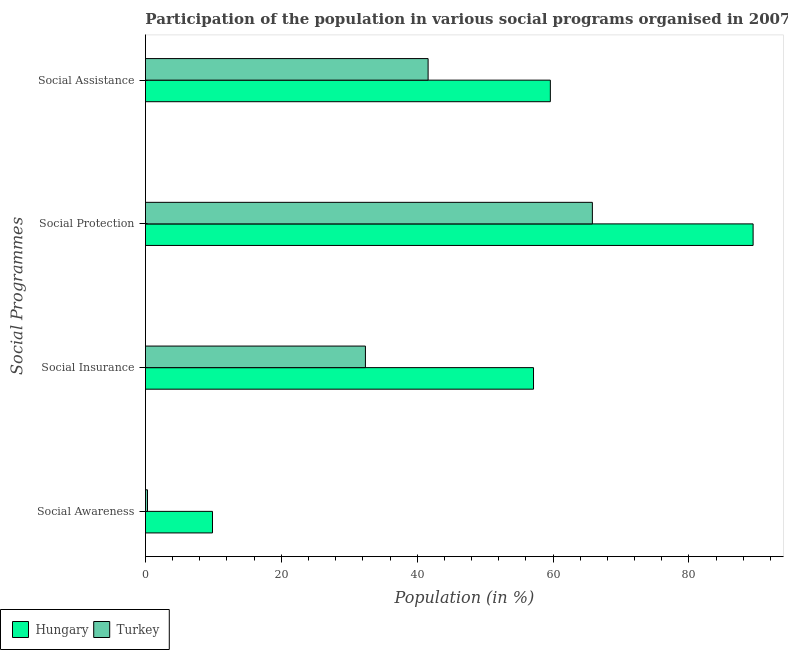How many different coloured bars are there?
Provide a short and direct response. 2. Are the number of bars per tick equal to the number of legend labels?
Your answer should be compact. Yes. Are the number of bars on each tick of the Y-axis equal?
Your answer should be very brief. Yes. How many bars are there on the 2nd tick from the top?
Give a very brief answer. 2. What is the label of the 4th group of bars from the top?
Keep it short and to the point. Social Awareness. What is the participation of population in social protection programs in Turkey?
Keep it short and to the point. 65.79. Across all countries, what is the maximum participation of population in social awareness programs?
Keep it short and to the point. 9.87. Across all countries, what is the minimum participation of population in social assistance programs?
Keep it short and to the point. 41.61. In which country was the participation of population in social insurance programs maximum?
Keep it short and to the point. Hungary. What is the total participation of population in social protection programs in the graph?
Your answer should be very brief. 155.23. What is the difference between the participation of population in social protection programs in Hungary and that in Turkey?
Your answer should be compact. 23.66. What is the difference between the participation of population in social insurance programs in Turkey and the participation of population in social awareness programs in Hungary?
Provide a short and direct response. 22.51. What is the average participation of population in social protection programs per country?
Provide a short and direct response. 77.62. What is the difference between the participation of population in social protection programs and participation of population in social insurance programs in Turkey?
Make the answer very short. 33.41. In how many countries, is the participation of population in social awareness programs greater than 72 %?
Provide a succinct answer. 0. What is the ratio of the participation of population in social insurance programs in Hungary to that in Turkey?
Ensure brevity in your answer.  1.76. Is the participation of population in social assistance programs in Hungary less than that in Turkey?
Your answer should be compact. No. What is the difference between the highest and the second highest participation of population in social assistance programs?
Offer a terse response. 17.99. What is the difference between the highest and the lowest participation of population in social awareness programs?
Provide a succinct answer. 9.57. Is it the case that in every country, the sum of the participation of population in social assistance programs and participation of population in social insurance programs is greater than the sum of participation of population in social awareness programs and participation of population in social protection programs?
Offer a very short reply. No. What does the 2nd bar from the top in Social Insurance represents?
Your answer should be compact. Hungary. What does the 1st bar from the bottom in Social Assistance represents?
Ensure brevity in your answer.  Hungary. Are all the bars in the graph horizontal?
Your answer should be compact. Yes. What is the difference between two consecutive major ticks on the X-axis?
Your response must be concise. 20. Does the graph contain any zero values?
Ensure brevity in your answer.  No. Does the graph contain grids?
Your answer should be compact. No. How many legend labels are there?
Your response must be concise. 2. How are the legend labels stacked?
Offer a terse response. Horizontal. What is the title of the graph?
Offer a terse response. Participation of the population in various social programs organised in 2007. What is the label or title of the X-axis?
Offer a very short reply. Population (in %). What is the label or title of the Y-axis?
Make the answer very short. Social Programmes. What is the Population (in %) of Hungary in Social Awareness?
Provide a short and direct response. 9.87. What is the Population (in %) of Turkey in Social Awareness?
Ensure brevity in your answer.  0.3. What is the Population (in %) of Hungary in Social Insurance?
Offer a very short reply. 57.12. What is the Population (in %) in Turkey in Social Insurance?
Give a very brief answer. 32.38. What is the Population (in %) of Hungary in Social Protection?
Keep it short and to the point. 89.44. What is the Population (in %) in Turkey in Social Protection?
Make the answer very short. 65.79. What is the Population (in %) in Hungary in Social Assistance?
Your response must be concise. 59.6. What is the Population (in %) of Turkey in Social Assistance?
Provide a short and direct response. 41.61. Across all Social Programmes, what is the maximum Population (in %) of Hungary?
Your response must be concise. 89.44. Across all Social Programmes, what is the maximum Population (in %) in Turkey?
Offer a terse response. 65.79. Across all Social Programmes, what is the minimum Population (in %) of Hungary?
Offer a terse response. 9.87. Across all Social Programmes, what is the minimum Population (in %) of Turkey?
Keep it short and to the point. 0.3. What is the total Population (in %) of Hungary in the graph?
Provide a short and direct response. 216.03. What is the total Population (in %) of Turkey in the graph?
Give a very brief answer. 140.07. What is the difference between the Population (in %) in Hungary in Social Awareness and that in Social Insurance?
Keep it short and to the point. -47.25. What is the difference between the Population (in %) in Turkey in Social Awareness and that in Social Insurance?
Keep it short and to the point. -32.08. What is the difference between the Population (in %) in Hungary in Social Awareness and that in Social Protection?
Give a very brief answer. -79.58. What is the difference between the Population (in %) of Turkey in Social Awareness and that in Social Protection?
Provide a succinct answer. -65.49. What is the difference between the Population (in %) in Hungary in Social Awareness and that in Social Assistance?
Provide a succinct answer. -49.73. What is the difference between the Population (in %) of Turkey in Social Awareness and that in Social Assistance?
Keep it short and to the point. -41.3. What is the difference between the Population (in %) of Hungary in Social Insurance and that in Social Protection?
Provide a short and direct response. -32.32. What is the difference between the Population (in %) in Turkey in Social Insurance and that in Social Protection?
Make the answer very short. -33.41. What is the difference between the Population (in %) in Hungary in Social Insurance and that in Social Assistance?
Provide a short and direct response. -2.48. What is the difference between the Population (in %) in Turkey in Social Insurance and that in Social Assistance?
Offer a very short reply. -9.23. What is the difference between the Population (in %) in Hungary in Social Protection and that in Social Assistance?
Make the answer very short. 29.85. What is the difference between the Population (in %) in Turkey in Social Protection and that in Social Assistance?
Keep it short and to the point. 24.18. What is the difference between the Population (in %) of Hungary in Social Awareness and the Population (in %) of Turkey in Social Insurance?
Your answer should be compact. -22.51. What is the difference between the Population (in %) in Hungary in Social Awareness and the Population (in %) in Turkey in Social Protection?
Your answer should be very brief. -55.92. What is the difference between the Population (in %) in Hungary in Social Awareness and the Population (in %) in Turkey in Social Assistance?
Your answer should be very brief. -31.74. What is the difference between the Population (in %) in Hungary in Social Insurance and the Population (in %) in Turkey in Social Protection?
Your response must be concise. -8.67. What is the difference between the Population (in %) in Hungary in Social Insurance and the Population (in %) in Turkey in Social Assistance?
Give a very brief answer. 15.52. What is the difference between the Population (in %) in Hungary in Social Protection and the Population (in %) in Turkey in Social Assistance?
Make the answer very short. 47.84. What is the average Population (in %) in Hungary per Social Programmes?
Ensure brevity in your answer.  54.01. What is the average Population (in %) in Turkey per Social Programmes?
Keep it short and to the point. 35.02. What is the difference between the Population (in %) of Hungary and Population (in %) of Turkey in Social Awareness?
Make the answer very short. 9.57. What is the difference between the Population (in %) of Hungary and Population (in %) of Turkey in Social Insurance?
Your answer should be very brief. 24.74. What is the difference between the Population (in %) of Hungary and Population (in %) of Turkey in Social Protection?
Your response must be concise. 23.66. What is the difference between the Population (in %) of Hungary and Population (in %) of Turkey in Social Assistance?
Ensure brevity in your answer.  17.99. What is the ratio of the Population (in %) of Hungary in Social Awareness to that in Social Insurance?
Offer a terse response. 0.17. What is the ratio of the Population (in %) of Turkey in Social Awareness to that in Social Insurance?
Make the answer very short. 0.01. What is the ratio of the Population (in %) in Hungary in Social Awareness to that in Social Protection?
Your answer should be very brief. 0.11. What is the ratio of the Population (in %) of Turkey in Social Awareness to that in Social Protection?
Your response must be concise. 0. What is the ratio of the Population (in %) of Hungary in Social Awareness to that in Social Assistance?
Provide a short and direct response. 0.17. What is the ratio of the Population (in %) in Turkey in Social Awareness to that in Social Assistance?
Ensure brevity in your answer.  0.01. What is the ratio of the Population (in %) of Hungary in Social Insurance to that in Social Protection?
Keep it short and to the point. 0.64. What is the ratio of the Population (in %) in Turkey in Social Insurance to that in Social Protection?
Provide a succinct answer. 0.49. What is the ratio of the Population (in %) of Hungary in Social Insurance to that in Social Assistance?
Offer a terse response. 0.96. What is the ratio of the Population (in %) of Turkey in Social Insurance to that in Social Assistance?
Give a very brief answer. 0.78. What is the ratio of the Population (in %) of Hungary in Social Protection to that in Social Assistance?
Ensure brevity in your answer.  1.5. What is the ratio of the Population (in %) in Turkey in Social Protection to that in Social Assistance?
Your answer should be very brief. 1.58. What is the difference between the highest and the second highest Population (in %) in Hungary?
Give a very brief answer. 29.85. What is the difference between the highest and the second highest Population (in %) of Turkey?
Provide a short and direct response. 24.18. What is the difference between the highest and the lowest Population (in %) in Hungary?
Your answer should be compact. 79.58. What is the difference between the highest and the lowest Population (in %) in Turkey?
Ensure brevity in your answer.  65.49. 